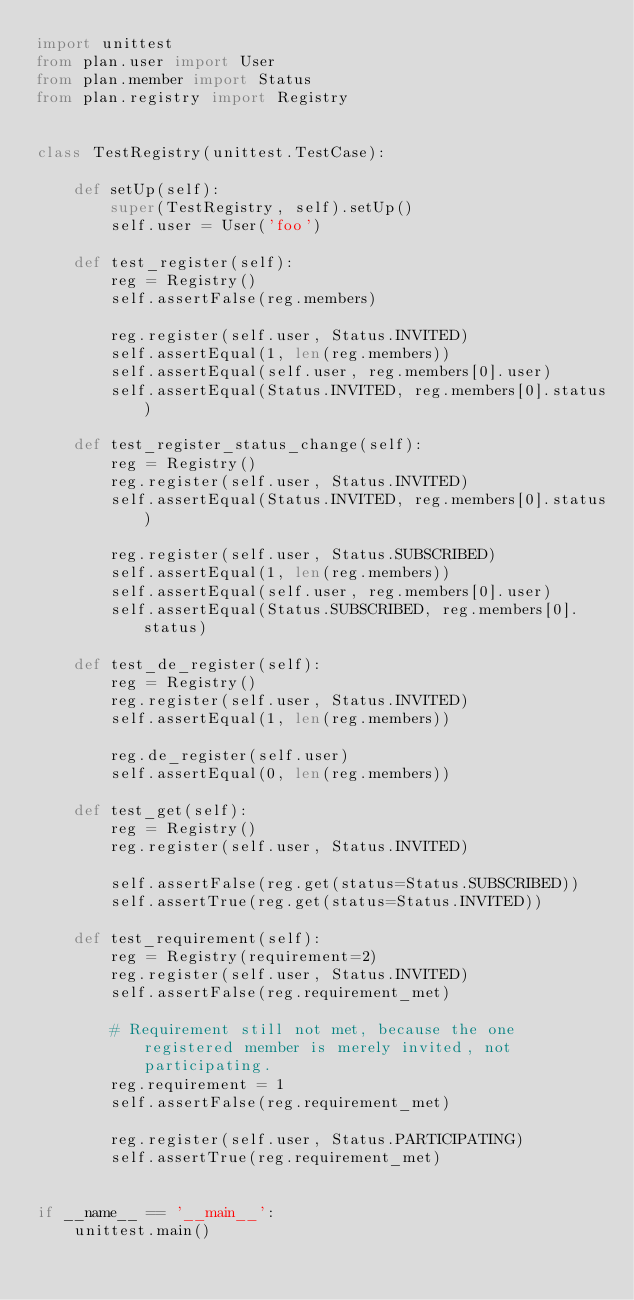<code> <loc_0><loc_0><loc_500><loc_500><_Python_>import unittest
from plan.user import User
from plan.member import Status
from plan.registry import Registry


class TestRegistry(unittest.TestCase):

    def setUp(self):
        super(TestRegistry, self).setUp()
        self.user = User('foo')

    def test_register(self):
        reg = Registry()
        self.assertFalse(reg.members)

        reg.register(self.user, Status.INVITED)
        self.assertEqual(1, len(reg.members))
        self.assertEqual(self.user, reg.members[0].user)
        self.assertEqual(Status.INVITED, reg.members[0].status)

    def test_register_status_change(self):
        reg = Registry()
        reg.register(self.user, Status.INVITED)
        self.assertEqual(Status.INVITED, reg.members[0].status)

        reg.register(self.user, Status.SUBSCRIBED)
        self.assertEqual(1, len(reg.members))
        self.assertEqual(self.user, reg.members[0].user)
        self.assertEqual(Status.SUBSCRIBED, reg.members[0].status)

    def test_de_register(self):
        reg = Registry()
        reg.register(self.user, Status.INVITED)
        self.assertEqual(1, len(reg.members))

        reg.de_register(self.user)
        self.assertEqual(0, len(reg.members))

    def test_get(self):
        reg = Registry()
        reg.register(self.user, Status.INVITED)

        self.assertFalse(reg.get(status=Status.SUBSCRIBED))
        self.assertTrue(reg.get(status=Status.INVITED))

    def test_requirement(self):
        reg = Registry(requirement=2)
        reg.register(self.user, Status.INVITED)
        self.assertFalse(reg.requirement_met)

        # Requirement still not met, because the one registered member is merely invited, not participating.
        reg.requirement = 1
        self.assertFalse(reg.requirement_met)

        reg.register(self.user, Status.PARTICIPATING)
        self.assertTrue(reg.requirement_met)


if __name__ == '__main__':
    unittest.main()
</code> 